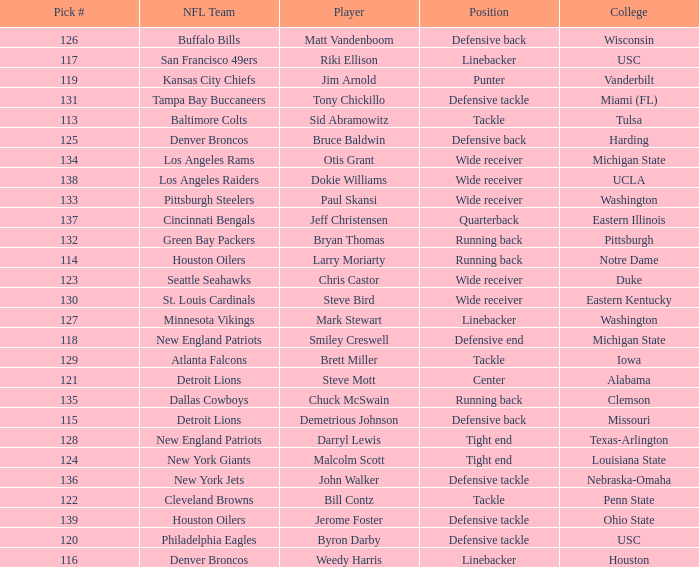How many players did the philadelphia eagles pick? 1.0. 